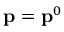Convert formula to latex. <formula><loc_0><loc_0><loc_500><loc_500>{ p } = { p } ^ { 0 }</formula> 